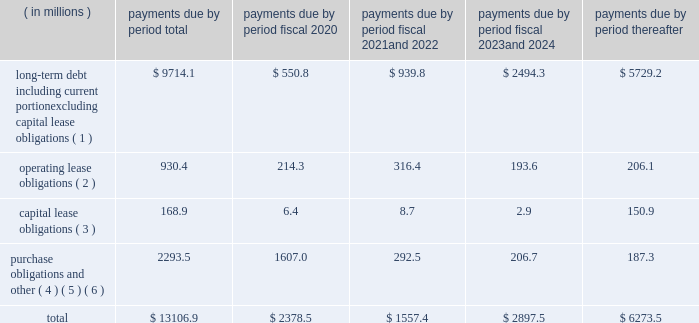Factors , including the market price of our common stock , general economic and market conditions and applicable legal requirements .
The repurchase program may be commenced , suspended or discontinued at any time .
In fiscal 2019 , we repurchased approximately 2.1 million shares of our common stock for an aggregate cost of $ 88.6 million .
In fiscal 2018 , we repurchased approximately 3.4 million shares of our common stock for an aggregate cost of $ 195.1 million .
As of september 30 , 2019 , we had approximately 19.1 million shares of common stock available for repurchase under the program .
We anticipate that we will be able to fund our capital expenditures , interest payments , dividends and stock repurchases , pension payments , working capital needs , note repurchases , restructuring activities , repayments of current portion of long-term debt and other corporate actions for the foreseeable future from cash generated from operations , borrowings under our credit facilities , proceeds from our a/r sales agreement , proceeds from the issuance of debt or equity securities or other additional long-term debt financing , including new or amended facilities .
In addition , we continually review our capital structure and conditions in the private and public debt markets in order to optimize our mix of indebtedness .
In connection with these reviews , we may seek to refinance existing indebtedness to extend maturities , reduce borrowing costs or otherwise improve the terms and composition of our indebtedness .
Contractual obligations we summarize our enforceable and legally binding contractual obligations at september 30 , 2019 , and the effect these obligations are expected to have on our liquidity and cash flow in future periods in the table .
Certain amounts in this table are based on management 2019s estimates and assumptions about these obligations , including their duration , the possibility of renewal , anticipated actions by third parties and other factors , including estimated minimum pension plan contributions and estimated benefit payments related to postretirement obligations , supplemental retirement plans and deferred compensation plans .
Because these estimates and assumptions are subjective , the enforceable and legally binding obligations we actually pay in future periods may vary from those presented in the table. .
( 1 ) includes only principal payments owed on our debt assuming that all of our long-term debt will be held to maturity , excluding scheduled payments .
We have excluded $ 163.5 million of fair value of debt step-up , deferred financing costs and unamortized bond discounts from the table to arrive at actual debt obligations .
See 201cnote 13 .
Debt 201d of the notes to consolidated financial statements for information on the interest rates that apply to our various debt instruments .
( 2 ) see 201cnote 15 .
Operating leases 201d of the notes to consolidated financial statements for additional information .
( 3 ) the fair value step-up of $ 16.9 million is excluded .
See 201cnote 13 .
Debt 2014 capital lease and other indebtedness 201d of the notes to consolidated financial statements for additional information .
( 4 ) purchase obligations include agreements to purchase goods or services that are enforceable and legally binding and that specify all significant terms , including : fixed or minimum quantities to be purchased ; fixed , minimum or variable price provision ; and the approximate timing of the transaction .
Purchase obligations exclude agreements that are cancelable without penalty .
( 5 ) we have included in the table future estimated minimum pension plan contributions and estimated benefit payments related to postretirement obligations , supplemental retirement plans and deferred compensation plans .
Our estimates are based on factors , such as discount rates and expected returns on plan assets .
Future contributions are subject to changes in our underfunded status based on factors such as investment performance , discount rates , returns on plan assets and changes in legislation .
It is possible that our assumptions may change , actual market performance may vary or we may decide to contribute different amounts .
We have excluded $ 237.2 million of multiemployer pension plan withdrawal liabilities recorded as of september 30 , 2019 , including our estimate of the accumulated funding deficiency , due to lack of .
What was the ratio of the share repurchase in 2019 to 2018? 
Computations: (2.1 / 3.4)
Answer: 0.61765. 